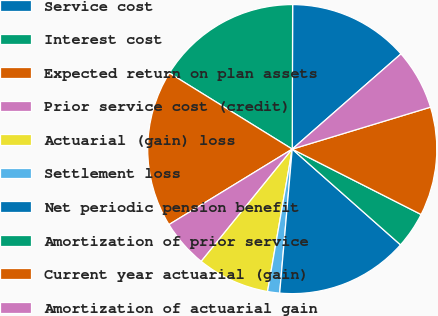Convert chart. <chart><loc_0><loc_0><loc_500><loc_500><pie_chart><fcel>Service cost<fcel>Interest cost<fcel>Expected return on plan assets<fcel>Prior service cost (credit)<fcel>Actuarial (gain) loss<fcel>Settlement loss<fcel>Net periodic pension benefit<fcel>Amortization of prior service<fcel>Current year actuarial (gain)<fcel>Amortization of actuarial gain<nl><fcel>13.51%<fcel>16.22%<fcel>17.57%<fcel>5.41%<fcel>8.11%<fcel>1.35%<fcel>14.86%<fcel>4.05%<fcel>12.16%<fcel>6.76%<nl></chart> 